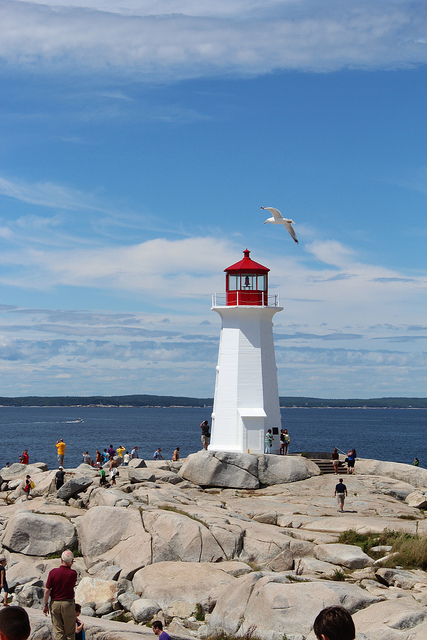How many remote controls are in the photo? There are no remote controls visible in the photo. The image shows an outdoor scene featuring a white lighthouse with a red cap on a rocky coastline, with people visiting the site and a clear blue sky above. 